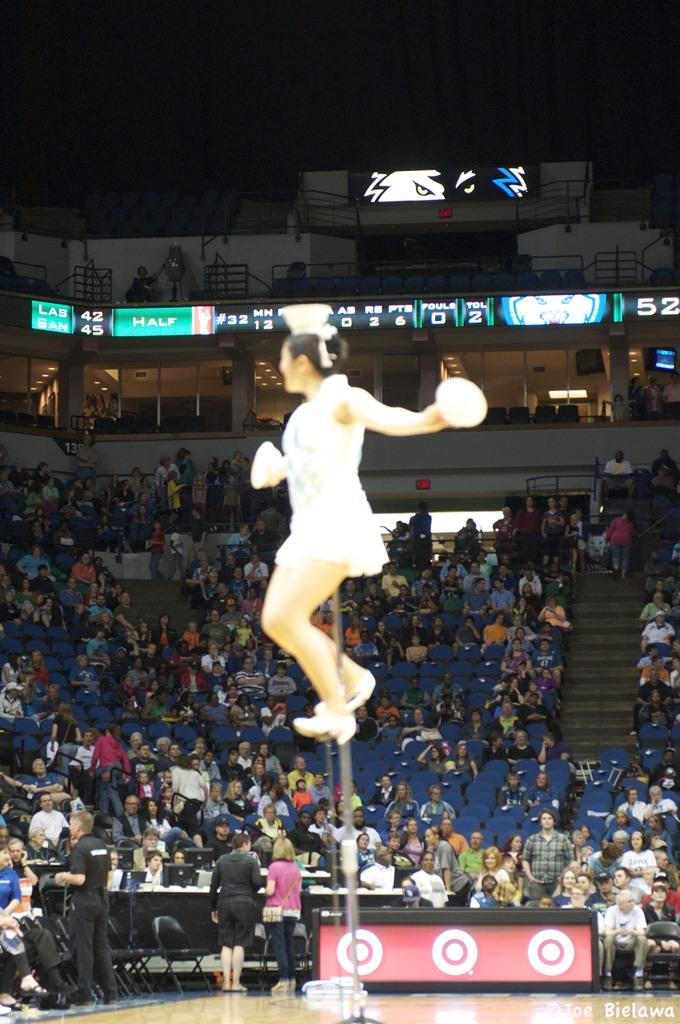What is the woman doing in the image? The woman is standing on an iron rod. What are the people around her doing? People are sitting on chairs. What type of structure can be seen in the image? There is a building in the image. What type of club is the woman holding in the image? There is no club present in the image; the woman is standing on an iron rod. Is the woman wearing a crown in the image? There is no crown present in the image; the woman is simply standing on an iron rod. 